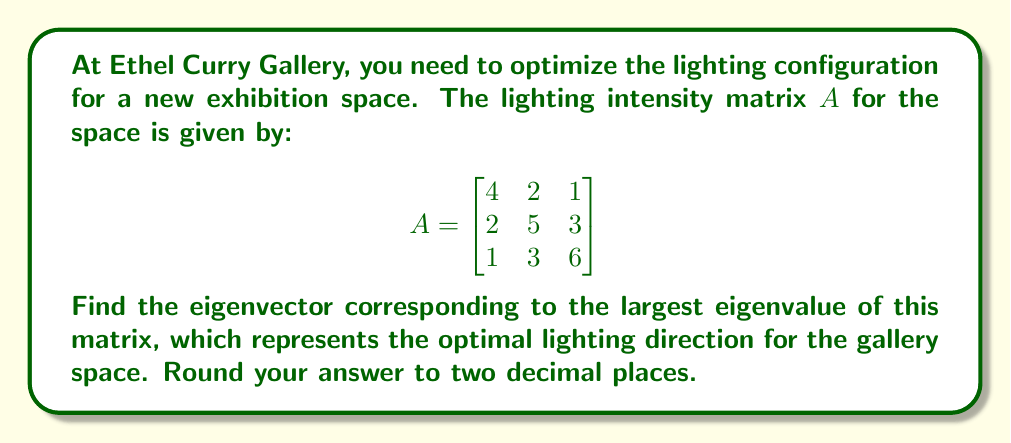Could you help me with this problem? To find the optimal lighting direction, we need to follow these steps:

1) First, calculate the eigenvalues of matrix $A$ by solving the characteristic equation:
   $\det(A - \lambda I) = 0$

2) Expand the determinant:
   $$\begin{vmatrix}
   4-\lambda & 2 & 1 \\
   2 & 5-\lambda & 3 \\
   1 & 3 & 6-\lambda
   \end{vmatrix} = 0$$

3) This gives us the characteristic polynomial:
   $-\lambda^3 + 15\lambda^2 - 66\lambda + 80 = 0$

4) Solve this equation to get the eigenvalues. The solutions are:
   $\lambda_1 = 8.37$ (rounded to 2 decimal places)
   $\lambda_2 = 4.79$
   $\lambda_3 = 1.84$

5) The largest eigenvalue is $\lambda_1 = 8.37$. We'll use this to find the corresponding eigenvector.

6) To find the eigenvector, solve $(A - \lambda_1 I)v = 0$:

   $$\begin{bmatrix}
   -4.37 & 2 & 1 \\
   2 & -3.37 & 3 \\
   1 & 3 & -2.37
   \end{bmatrix} \begin{bmatrix} v_1 \\ v_2 \\ v_3 \end{bmatrix} = \begin{bmatrix} 0 \\ 0 \\ 0 \end{bmatrix}$$

7) Solve this system of equations. One solution is:
   $v_1 = 0.52$
   $v_2 = 0.60$
   $v_3 = 0.61$

8) Normalize this vector to get the unit eigenvector:
   $$\frac{1}{\sqrt{0.52^2 + 0.60^2 + 0.61^2}} \begin{bmatrix} 0.52 \\ 0.60 \\ 0.61 \end{bmatrix} = \begin{bmatrix} 0.52 \\ 0.60 \\ 0.61 \end{bmatrix}$$

This normalized vector is already rounded to two decimal places and represents the optimal lighting direction.
Answer: $[0.52, 0.60, 0.61]$ 